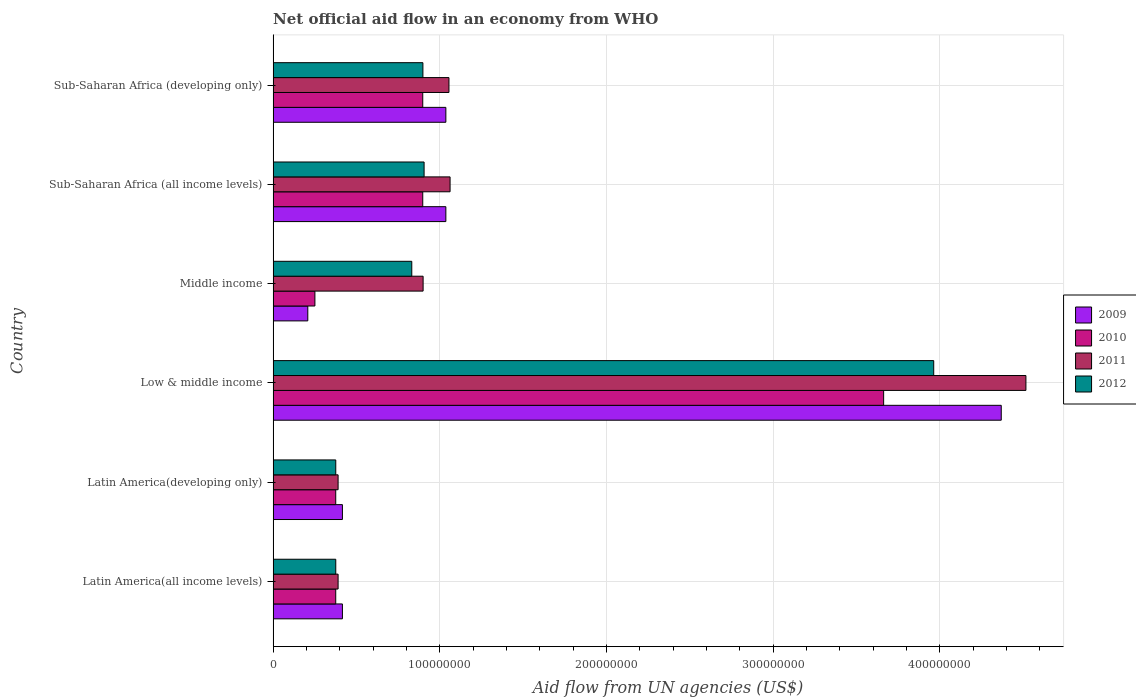Are the number of bars per tick equal to the number of legend labels?
Give a very brief answer. Yes. Are the number of bars on each tick of the Y-axis equal?
Provide a short and direct response. Yes. How many bars are there on the 6th tick from the top?
Offer a terse response. 4. How many bars are there on the 2nd tick from the bottom?
Provide a short and direct response. 4. What is the label of the 6th group of bars from the top?
Keep it short and to the point. Latin America(all income levels). What is the net official aid flow in 2010 in Latin America(all income levels)?
Your answer should be compact. 3.76e+07. Across all countries, what is the maximum net official aid flow in 2010?
Keep it short and to the point. 3.66e+08. Across all countries, what is the minimum net official aid flow in 2010?
Your answer should be compact. 2.51e+07. What is the total net official aid flow in 2012 in the graph?
Your answer should be very brief. 7.35e+08. What is the difference between the net official aid flow in 2010 in Middle income and that in Sub-Saharan Africa (all income levels)?
Offer a very short reply. -6.47e+07. What is the difference between the net official aid flow in 2012 in Sub-Saharan Africa (all income levels) and the net official aid flow in 2009 in Low & middle income?
Give a very brief answer. -3.46e+08. What is the average net official aid flow in 2010 per country?
Your response must be concise. 1.08e+08. What is the difference between the net official aid flow in 2009 and net official aid flow in 2011 in Sub-Saharan Africa (all income levels)?
Offer a terse response. -2.53e+06. In how many countries, is the net official aid flow in 2012 greater than 40000000 US$?
Make the answer very short. 4. What is the ratio of the net official aid flow in 2010 in Latin America(developing only) to that in Sub-Saharan Africa (all income levels)?
Your answer should be compact. 0.42. Is the net official aid flow in 2010 in Middle income less than that in Sub-Saharan Africa (all income levels)?
Offer a terse response. Yes. Is the difference between the net official aid flow in 2009 in Latin America(developing only) and Sub-Saharan Africa (developing only) greater than the difference between the net official aid flow in 2011 in Latin America(developing only) and Sub-Saharan Africa (developing only)?
Your response must be concise. Yes. What is the difference between the highest and the second highest net official aid flow in 2009?
Your answer should be compact. 3.33e+08. What is the difference between the highest and the lowest net official aid flow in 2010?
Your answer should be very brief. 3.41e+08. Is the sum of the net official aid flow in 2011 in Latin America(developing only) and Sub-Saharan Africa (all income levels) greater than the maximum net official aid flow in 2010 across all countries?
Make the answer very short. No. Is it the case that in every country, the sum of the net official aid flow in 2009 and net official aid flow in 2011 is greater than the net official aid flow in 2012?
Ensure brevity in your answer.  Yes. Are all the bars in the graph horizontal?
Offer a very short reply. Yes. How many countries are there in the graph?
Offer a very short reply. 6. Are the values on the major ticks of X-axis written in scientific E-notation?
Give a very brief answer. No. How many legend labels are there?
Your answer should be compact. 4. How are the legend labels stacked?
Your answer should be very brief. Vertical. What is the title of the graph?
Your response must be concise. Net official aid flow in an economy from WHO. What is the label or title of the X-axis?
Offer a very short reply. Aid flow from UN agencies (US$). What is the Aid flow from UN agencies (US$) in 2009 in Latin America(all income levels)?
Ensure brevity in your answer.  4.16e+07. What is the Aid flow from UN agencies (US$) of 2010 in Latin America(all income levels)?
Keep it short and to the point. 3.76e+07. What is the Aid flow from UN agencies (US$) in 2011 in Latin America(all income levels)?
Offer a very short reply. 3.90e+07. What is the Aid flow from UN agencies (US$) in 2012 in Latin America(all income levels)?
Give a very brief answer. 3.76e+07. What is the Aid flow from UN agencies (US$) in 2009 in Latin America(developing only)?
Keep it short and to the point. 4.16e+07. What is the Aid flow from UN agencies (US$) of 2010 in Latin America(developing only)?
Offer a terse response. 3.76e+07. What is the Aid flow from UN agencies (US$) in 2011 in Latin America(developing only)?
Your response must be concise. 3.90e+07. What is the Aid flow from UN agencies (US$) in 2012 in Latin America(developing only)?
Provide a succinct answer. 3.76e+07. What is the Aid flow from UN agencies (US$) in 2009 in Low & middle income?
Keep it short and to the point. 4.37e+08. What is the Aid flow from UN agencies (US$) of 2010 in Low & middle income?
Offer a terse response. 3.66e+08. What is the Aid flow from UN agencies (US$) in 2011 in Low & middle income?
Offer a terse response. 4.52e+08. What is the Aid flow from UN agencies (US$) of 2012 in Low & middle income?
Offer a very short reply. 3.96e+08. What is the Aid flow from UN agencies (US$) of 2009 in Middle income?
Ensure brevity in your answer.  2.08e+07. What is the Aid flow from UN agencies (US$) in 2010 in Middle income?
Offer a very short reply. 2.51e+07. What is the Aid flow from UN agencies (US$) of 2011 in Middle income?
Your answer should be very brief. 9.00e+07. What is the Aid flow from UN agencies (US$) in 2012 in Middle income?
Keep it short and to the point. 8.32e+07. What is the Aid flow from UN agencies (US$) in 2009 in Sub-Saharan Africa (all income levels)?
Offer a terse response. 1.04e+08. What is the Aid flow from UN agencies (US$) of 2010 in Sub-Saharan Africa (all income levels)?
Provide a succinct answer. 8.98e+07. What is the Aid flow from UN agencies (US$) in 2011 in Sub-Saharan Africa (all income levels)?
Provide a short and direct response. 1.06e+08. What is the Aid flow from UN agencies (US$) of 2012 in Sub-Saharan Africa (all income levels)?
Your answer should be compact. 9.06e+07. What is the Aid flow from UN agencies (US$) in 2009 in Sub-Saharan Africa (developing only)?
Ensure brevity in your answer.  1.04e+08. What is the Aid flow from UN agencies (US$) of 2010 in Sub-Saharan Africa (developing only)?
Offer a very short reply. 8.98e+07. What is the Aid flow from UN agencies (US$) of 2011 in Sub-Saharan Africa (developing only)?
Offer a terse response. 1.05e+08. What is the Aid flow from UN agencies (US$) of 2012 in Sub-Saharan Africa (developing only)?
Provide a short and direct response. 8.98e+07. Across all countries, what is the maximum Aid flow from UN agencies (US$) of 2009?
Offer a very short reply. 4.37e+08. Across all countries, what is the maximum Aid flow from UN agencies (US$) of 2010?
Your answer should be very brief. 3.66e+08. Across all countries, what is the maximum Aid flow from UN agencies (US$) in 2011?
Your answer should be very brief. 4.52e+08. Across all countries, what is the maximum Aid flow from UN agencies (US$) in 2012?
Your answer should be very brief. 3.96e+08. Across all countries, what is the minimum Aid flow from UN agencies (US$) of 2009?
Offer a terse response. 2.08e+07. Across all countries, what is the minimum Aid flow from UN agencies (US$) of 2010?
Offer a terse response. 2.51e+07. Across all countries, what is the minimum Aid flow from UN agencies (US$) of 2011?
Provide a succinct answer. 3.90e+07. Across all countries, what is the minimum Aid flow from UN agencies (US$) in 2012?
Your answer should be compact. 3.76e+07. What is the total Aid flow from UN agencies (US$) in 2009 in the graph?
Provide a succinct answer. 7.48e+08. What is the total Aid flow from UN agencies (US$) of 2010 in the graph?
Your response must be concise. 6.46e+08. What is the total Aid flow from UN agencies (US$) in 2011 in the graph?
Make the answer very short. 8.31e+08. What is the total Aid flow from UN agencies (US$) in 2012 in the graph?
Keep it short and to the point. 7.35e+08. What is the difference between the Aid flow from UN agencies (US$) of 2010 in Latin America(all income levels) and that in Latin America(developing only)?
Your response must be concise. 0. What is the difference between the Aid flow from UN agencies (US$) of 2011 in Latin America(all income levels) and that in Latin America(developing only)?
Ensure brevity in your answer.  0. What is the difference between the Aid flow from UN agencies (US$) in 2009 in Latin America(all income levels) and that in Low & middle income?
Your answer should be very brief. -3.95e+08. What is the difference between the Aid flow from UN agencies (US$) in 2010 in Latin America(all income levels) and that in Low & middle income?
Make the answer very short. -3.29e+08. What is the difference between the Aid flow from UN agencies (US$) of 2011 in Latin America(all income levels) and that in Low & middle income?
Provide a succinct answer. -4.13e+08. What is the difference between the Aid flow from UN agencies (US$) in 2012 in Latin America(all income levels) and that in Low & middle income?
Your answer should be compact. -3.59e+08. What is the difference between the Aid flow from UN agencies (US$) of 2009 in Latin America(all income levels) and that in Middle income?
Your answer should be compact. 2.08e+07. What is the difference between the Aid flow from UN agencies (US$) in 2010 in Latin America(all income levels) and that in Middle income?
Keep it short and to the point. 1.25e+07. What is the difference between the Aid flow from UN agencies (US$) in 2011 in Latin America(all income levels) and that in Middle income?
Provide a succinct answer. -5.10e+07. What is the difference between the Aid flow from UN agencies (US$) of 2012 in Latin America(all income levels) and that in Middle income?
Your answer should be compact. -4.56e+07. What is the difference between the Aid flow from UN agencies (US$) in 2009 in Latin America(all income levels) and that in Sub-Saharan Africa (all income levels)?
Make the answer very short. -6.20e+07. What is the difference between the Aid flow from UN agencies (US$) of 2010 in Latin America(all income levels) and that in Sub-Saharan Africa (all income levels)?
Make the answer very short. -5.22e+07. What is the difference between the Aid flow from UN agencies (US$) in 2011 in Latin America(all income levels) and that in Sub-Saharan Africa (all income levels)?
Make the answer very short. -6.72e+07. What is the difference between the Aid flow from UN agencies (US$) of 2012 in Latin America(all income levels) and that in Sub-Saharan Africa (all income levels)?
Your answer should be very brief. -5.30e+07. What is the difference between the Aid flow from UN agencies (US$) in 2009 in Latin America(all income levels) and that in Sub-Saharan Africa (developing only)?
Keep it short and to the point. -6.20e+07. What is the difference between the Aid flow from UN agencies (US$) of 2010 in Latin America(all income levels) and that in Sub-Saharan Africa (developing only)?
Offer a very short reply. -5.22e+07. What is the difference between the Aid flow from UN agencies (US$) in 2011 in Latin America(all income levels) and that in Sub-Saharan Africa (developing only)?
Your answer should be compact. -6.65e+07. What is the difference between the Aid flow from UN agencies (US$) in 2012 in Latin America(all income levels) and that in Sub-Saharan Africa (developing only)?
Offer a terse response. -5.23e+07. What is the difference between the Aid flow from UN agencies (US$) in 2009 in Latin America(developing only) and that in Low & middle income?
Your answer should be compact. -3.95e+08. What is the difference between the Aid flow from UN agencies (US$) in 2010 in Latin America(developing only) and that in Low & middle income?
Your response must be concise. -3.29e+08. What is the difference between the Aid flow from UN agencies (US$) of 2011 in Latin America(developing only) and that in Low & middle income?
Keep it short and to the point. -4.13e+08. What is the difference between the Aid flow from UN agencies (US$) in 2012 in Latin America(developing only) and that in Low & middle income?
Keep it short and to the point. -3.59e+08. What is the difference between the Aid flow from UN agencies (US$) in 2009 in Latin America(developing only) and that in Middle income?
Offer a very short reply. 2.08e+07. What is the difference between the Aid flow from UN agencies (US$) in 2010 in Latin America(developing only) and that in Middle income?
Your answer should be very brief. 1.25e+07. What is the difference between the Aid flow from UN agencies (US$) of 2011 in Latin America(developing only) and that in Middle income?
Provide a short and direct response. -5.10e+07. What is the difference between the Aid flow from UN agencies (US$) of 2012 in Latin America(developing only) and that in Middle income?
Offer a terse response. -4.56e+07. What is the difference between the Aid flow from UN agencies (US$) in 2009 in Latin America(developing only) and that in Sub-Saharan Africa (all income levels)?
Give a very brief answer. -6.20e+07. What is the difference between the Aid flow from UN agencies (US$) in 2010 in Latin America(developing only) and that in Sub-Saharan Africa (all income levels)?
Give a very brief answer. -5.22e+07. What is the difference between the Aid flow from UN agencies (US$) of 2011 in Latin America(developing only) and that in Sub-Saharan Africa (all income levels)?
Ensure brevity in your answer.  -6.72e+07. What is the difference between the Aid flow from UN agencies (US$) of 2012 in Latin America(developing only) and that in Sub-Saharan Africa (all income levels)?
Your answer should be very brief. -5.30e+07. What is the difference between the Aid flow from UN agencies (US$) of 2009 in Latin America(developing only) and that in Sub-Saharan Africa (developing only)?
Your response must be concise. -6.20e+07. What is the difference between the Aid flow from UN agencies (US$) in 2010 in Latin America(developing only) and that in Sub-Saharan Africa (developing only)?
Ensure brevity in your answer.  -5.22e+07. What is the difference between the Aid flow from UN agencies (US$) in 2011 in Latin America(developing only) and that in Sub-Saharan Africa (developing only)?
Give a very brief answer. -6.65e+07. What is the difference between the Aid flow from UN agencies (US$) of 2012 in Latin America(developing only) and that in Sub-Saharan Africa (developing only)?
Keep it short and to the point. -5.23e+07. What is the difference between the Aid flow from UN agencies (US$) of 2009 in Low & middle income and that in Middle income?
Ensure brevity in your answer.  4.16e+08. What is the difference between the Aid flow from UN agencies (US$) in 2010 in Low & middle income and that in Middle income?
Your answer should be very brief. 3.41e+08. What is the difference between the Aid flow from UN agencies (US$) of 2011 in Low & middle income and that in Middle income?
Provide a short and direct response. 3.62e+08. What is the difference between the Aid flow from UN agencies (US$) in 2012 in Low & middle income and that in Middle income?
Your response must be concise. 3.13e+08. What is the difference between the Aid flow from UN agencies (US$) of 2009 in Low & middle income and that in Sub-Saharan Africa (all income levels)?
Offer a very short reply. 3.33e+08. What is the difference between the Aid flow from UN agencies (US$) of 2010 in Low & middle income and that in Sub-Saharan Africa (all income levels)?
Give a very brief answer. 2.76e+08. What is the difference between the Aid flow from UN agencies (US$) in 2011 in Low & middle income and that in Sub-Saharan Africa (all income levels)?
Offer a very short reply. 3.45e+08. What is the difference between the Aid flow from UN agencies (US$) of 2012 in Low & middle income and that in Sub-Saharan Africa (all income levels)?
Offer a terse response. 3.06e+08. What is the difference between the Aid flow from UN agencies (US$) of 2009 in Low & middle income and that in Sub-Saharan Africa (developing only)?
Provide a short and direct response. 3.33e+08. What is the difference between the Aid flow from UN agencies (US$) of 2010 in Low & middle income and that in Sub-Saharan Africa (developing only)?
Your response must be concise. 2.76e+08. What is the difference between the Aid flow from UN agencies (US$) in 2011 in Low & middle income and that in Sub-Saharan Africa (developing only)?
Offer a terse response. 3.46e+08. What is the difference between the Aid flow from UN agencies (US$) in 2012 in Low & middle income and that in Sub-Saharan Africa (developing only)?
Your answer should be compact. 3.06e+08. What is the difference between the Aid flow from UN agencies (US$) in 2009 in Middle income and that in Sub-Saharan Africa (all income levels)?
Your response must be concise. -8.28e+07. What is the difference between the Aid flow from UN agencies (US$) in 2010 in Middle income and that in Sub-Saharan Africa (all income levels)?
Provide a succinct answer. -6.47e+07. What is the difference between the Aid flow from UN agencies (US$) of 2011 in Middle income and that in Sub-Saharan Africa (all income levels)?
Keep it short and to the point. -1.62e+07. What is the difference between the Aid flow from UN agencies (US$) of 2012 in Middle income and that in Sub-Saharan Africa (all income levels)?
Give a very brief answer. -7.39e+06. What is the difference between the Aid flow from UN agencies (US$) of 2009 in Middle income and that in Sub-Saharan Africa (developing only)?
Your response must be concise. -8.28e+07. What is the difference between the Aid flow from UN agencies (US$) in 2010 in Middle income and that in Sub-Saharan Africa (developing only)?
Make the answer very short. -6.47e+07. What is the difference between the Aid flow from UN agencies (US$) in 2011 in Middle income and that in Sub-Saharan Africa (developing only)?
Your answer should be very brief. -1.55e+07. What is the difference between the Aid flow from UN agencies (US$) in 2012 in Middle income and that in Sub-Saharan Africa (developing only)?
Keep it short and to the point. -6.67e+06. What is the difference between the Aid flow from UN agencies (US$) in 2009 in Sub-Saharan Africa (all income levels) and that in Sub-Saharan Africa (developing only)?
Your answer should be compact. 0. What is the difference between the Aid flow from UN agencies (US$) of 2010 in Sub-Saharan Africa (all income levels) and that in Sub-Saharan Africa (developing only)?
Keep it short and to the point. 0. What is the difference between the Aid flow from UN agencies (US$) in 2011 in Sub-Saharan Africa (all income levels) and that in Sub-Saharan Africa (developing only)?
Provide a short and direct response. 6.70e+05. What is the difference between the Aid flow from UN agencies (US$) in 2012 in Sub-Saharan Africa (all income levels) and that in Sub-Saharan Africa (developing only)?
Offer a very short reply. 7.20e+05. What is the difference between the Aid flow from UN agencies (US$) in 2009 in Latin America(all income levels) and the Aid flow from UN agencies (US$) in 2010 in Latin America(developing only)?
Keep it short and to the point. 4.01e+06. What is the difference between the Aid flow from UN agencies (US$) of 2009 in Latin America(all income levels) and the Aid flow from UN agencies (US$) of 2011 in Latin America(developing only)?
Give a very brief answer. 2.59e+06. What is the difference between the Aid flow from UN agencies (US$) in 2009 in Latin America(all income levels) and the Aid flow from UN agencies (US$) in 2012 in Latin America(developing only)?
Your response must be concise. 3.99e+06. What is the difference between the Aid flow from UN agencies (US$) in 2010 in Latin America(all income levels) and the Aid flow from UN agencies (US$) in 2011 in Latin America(developing only)?
Provide a succinct answer. -1.42e+06. What is the difference between the Aid flow from UN agencies (US$) of 2011 in Latin America(all income levels) and the Aid flow from UN agencies (US$) of 2012 in Latin America(developing only)?
Make the answer very short. 1.40e+06. What is the difference between the Aid flow from UN agencies (US$) of 2009 in Latin America(all income levels) and the Aid flow from UN agencies (US$) of 2010 in Low & middle income?
Make the answer very short. -3.25e+08. What is the difference between the Aid flow from UN agencies (US$) of 2009 in Latin America(all income levels) and the Aid flow from UN agencies (US$) of 2011 in Low & middle income?
Your answer should be compact. -4.10e+08. What is the difference between the Aid flow from UN agencies (US$) in 2009 in Latin America(all income levels) and the Aid flow from UN agencies (US$) in 2012 in Low & middle income?
Make the answer very short. -3.55e+08. What is the difference between the Aid flow from UN agencies (US$) of 2010 in Latin America(all income levels) and the Aid flow from UN agencies (US$) of 2011 in Low & middle income?
Provide a succinct answer. -4.14e+08. What is the difference between the Aid flow from UN agencies (US$) of 2010 in Latin America(all income levels) and the Aid flow from UN agencies (US$) of 2012 in Low & middle income?
Your response must be concise. -3.59e+08. What is the difference between the Aid flow from UN agencies (US$) of 2011 in Latin America(all income levels) and the Aid flow from UN agencies (US$) of 2012 in Low & middle income?
Ensure brevity in your answer.  -3.57e+08. What is the difference between the Aid flow from UN agencies (US$) of 2009 in Latin America(all income levels) and the Aid flow from UN agencies (US$) of 2010 in Middle income?
Keep it short and to the point. 1.65e+07. What is the difference between the Aid flow from UN agencies (US$) of 2009 in Latin America(all income levels) and the Aid flow from UN agencies (US$) of 2011 in Middle income?
Offer a very short reply. -4.84e+07. What is the difference between the Aid flow from UN agencies (US$) of 2009 in Latin America(all income levels) and the Aid flow from UN agencies (US$) of 2012 in Middle income?
Your answer should be compact. -4.16e+07. What is the difference between the Aid flow from UN agencies (US$) in 2010 in Latin America(all income levels) and the Aid flow from UN agencies (US$) in 2011 in Middle income?
Your answer should be compact. -5.24e+07. What is the difference between the Aid flow from UN agencies (US$) of 2010 in Latin America(all income levels) and the Aid flow from UN agencies (US$) of 2012 in Middle income?
Make the answer very short. -4.56e+07. What is the difference between the Aid flow from UN agencies (US$) of 2011 in Latin America(all income levels) and the Aid flow from UN agencies (US$) of 2012 in Middle income?
Offer a terse response. -4.42e+07. What is the difference between the Aid flow from UN agencies (US$) in 2009 in Latin America(all income levels) and the Aid flow from UN agencies (US$) in 2010 in Sub-Saharan Africa (all income levels)?
Offer a very short reply. -4.82e+07. What is the difference between the Aid flow from UN agencies (US$) in 2009 in Latin America(all income levels) and the Aid flow from UN agencies (US$) in 2011 in Sub-Saharan Africa (all income levels)?
Your answer should be compact. -6.46e+07. What is the difference between the Aid flow from UN agencies (US$) of 2009 in Latin America(all income levels) and the Aid flow from UN agencies (US$) of 2012 in Sub-Saharan Africa (all income levels)?
Offer a very short reply. -4.90e+07. What is the difference between the Aid flow from UN agencies (US$) in 2010 in Latin America(all income levels) and the Aid flow from UN agencies (US$) in 2011 in Sub-Saharan Africa (all income levels)?
Give a very brief answer. -6.86e+07. What is the difference between the Aid flow from UN agencies (US$) in 2010 in Latin America(all income levels) and the Aid flow from UN agencies (US$) in 2012 in Sub-Saharan Africa (all income levels)?
Offer a very short reply. -5.30e+07. What is the difference between the Aid flow from UN agencies (US$) of 2011 in Latin America(all income levels) and the Aid flow from UN agencies (US$) of 2012 in Sub-Saharan Africa (all income levels)?
Your answer should be compact. -5.16e+07. What is the difference between the Aid flow from UN agencies (US$) in 2009 in Latin America(all income levels) and the Aid flow from UN agencies (US$) in 2010 in Sub-Saharan Africa (developing only)?
Provide a succinct answer. -4.82e+07. What is the difference between the Aid flow from UN agencies (US$) in 2009 in Latin America(all income levels) and the Aid flow from UN agencies (US$) in 2011 in Sub-Saharan Africa (developing only)?
Your response must be concise. -6.39e+07. What is the difference between the Aid flow from UN agencies (US$) of 2009 in Latin America(all income levels) and the Aid flow from UN agencies (US$) of 2012 in Sub-Saharan Africa (developing only)?
Ensure brevity in your answer.  -4.83e+07. What is the difference between the Aid flow from UN agencies (US$) of 2010 in Latin America(all income levels) and the Aid flow from UN agencies (US$) of 2011 in Sub-Saharan Africa (developing only)?
Give a very brief answer. -6.79e+07. What is the difference between the Aid flow from UN agencies (US$) of 2010 in Latin America(all income levels) and the Aid flow from UN agencies (US$) of 2012 in Sub-Saharan Africa (developing only)?
Your response must be concise. -5.23e+07. What is the difference between the Aid flow from UN agencies (US$) in 2011 in Latin America(all income levels) and the Aid flow from UN agencies (US$) in 2012 in Sub-Saharan Africa (developing only)?
Provide a succinct answer. -5.09e+07. What is the difference between the Aid flow from UN agencies (US$) in 2009 in Latin America(developing only) and the Aid flow from UN agencies (US$) in 2010 in Low & middle income?
Offer a very short reply. -3.25e+08. What is the difference between the Aid flow from UN agencies (US$) of 2009 in Latin America(developing only) and the Aid flow from UN agencies (US$) of 2011 in Low & middle income?
Provide a succinct answer. -4.10e+08. What is the difference between the Aid flow from UN agencies (US$) in 2009 in Latin America(developing only) and the Aid flow from UN agencies (US$) in 2012 in Low & middle income?
Provide a short and direct response. -3.55e+08. What is the difference between the Aid flow from UN agencies (US$) of 2010 in Latin America(developing only) and the Aid flow from UN agencies (US$) of 2011 in Low & middle income?
Provide a short and direct response. -4.14e+08. What is the difference between the Aid flow from UN agencies (US$) in 2010 in Latin America(developing only) and the Aid flow from UN agencies (US$) in 2012 in Low & middle income?
Keep it short and to the point. -3.59e+08. What is the difference between the Aid flow from UN agencies (US$) in 2011 in Latin America(developing only) and the Aid flow from UN agencies (US$) in 2012 in Low & middle income?
Your response must be concise. -3.57e+08. What is the difference between the Aid flow from UN agencies (US$) of 2009 in Latin America(developing only) and the Aid flow from UN agencies (US$) of 2010 in Middle income?
Provide a succinct answer. 1.65e+07. What is the difference between the Aid flow from UN agencies (US$) in 2009 in Latin America(developing only) and the Aid flow from UN agencies (US$) in 2011 in Middle income?
Provide a short and direct response. -4.84e+07. What is the difference between the Aid flow from UN agencies (US$) in 2009 in Latin America(developing only) and the Aid flow from UN agencies (US$) in 2012 in Middle income?
Provide a succinct answer. -4.16e+07. What is the difference between the Aid flow from UN agencies (US$) in 2010 in Latin America(developing only) and the Aid flow from UN agencies (US$) in 2011 in Middle income?
Make the answer very short. -5.24e+07. What is the difference between the Aid flow from UN agencies (US$) in 2010 in Latin America(developing only) and the Aid flow from UN agencies (US$) in 2012 in Middle income?
Offer a terse response. -4.56e+07. What is the difference between the Aid flow from UN agencies (US$) of 2011 in Latin America(developing only) and the Aid flow from UN agencies (US$) of 2012 in Middle income?
Give a very brief answer. -4.42e+07. What is the difference between the Aid flow from UN agencies (US$) of 2009 in Latin America(developing only) and the Aid flow from UN agencies (US$) of 2010 in Sub-Saharan Africa (all income levels)?
Make the answer very short. -4.82e+07. What is the difference between the Aid flow from UN agencies (US$) of 2009 in Latin America(developing only) and the Aid flow from UN agencies (US$) of 2011 in Sub-Saharan Africa (all income levels)?
Offer a very short reply. -6.46e+07. What is the difference between the Aid flow from UN agencies (US$) of 2009 in Latin America(developing only) and the Aid flow from UN agencies (US$) of 2012 in Sub-Saharan Africa (all income levels)?
Make the answer very short. -4.90e+07. What is the difference between the Aid flow from UN agencies (US$) of 2010 in Latin America(developing only) and the Aid flow from UN agencies (US$) of 2011 in Sub-Saharan Africa (all income levels)?
Provide a succinct answer. -6.86e+07. What is the difference between the Aid flow from UN agencies (US$) of 2010 in Latin America(developing only) and the Aid flow from UN agencies (US$) of 2012 in Sub-Saharan Africa (all income levels)?
Ensure brevity in your answer.  -5.30e+07. What is the difference between the Aid flow from UN agencies (US$) in 2011 in Latin America(developing only) and the Aid flow from UN agencies (US$) in 2012 in Sub-Saharan Africa (all income levels)?
Give a very brief answer. -5.16e+07. What is the difference between the Aid flow from UN agencies (US$) in 2009 in Latin America(developing only) and the Aid flow from UN agencies (US$) in 2010 in Sub-Saharan Africa (developing only)?
Your response must be concise. -4.82e+07. What is the difference between the Aid flow from UN agencies (US$) in 2009 in Latin America(developing only) and the Aid flow from UN agencies (US$) in 2011 in Sub-Saharan Africa (developing only)?
Your response must be concise. -6.39e+07. What is the difference between the Aid flow from UN agencies (US$) in 2009 in Latin America(developing only) and the Aid flow from UN agencies (US$) in 2012 in Sub-Saharan Africa (developing only)?
Give a very brief answer. -4.83e+07. What is the difference between the Aid flow from UN agencies (US$) in 2010 in Latin America(developing only) and the Aid flow from UN agencies (US$) in 2011 in Sub-Saharan Africa (developing only)?
Your answer should be compact. -6.79e+07. What is the difference between the Aid flow from UN agencies (US$) in 2010 in Latin America(developing only) and the Aid flow from UN agencies (US$) in 2012 in Sub-Saharan Africa (developing only)?
Provide a succinct answer. -5.23e+07. What is the difference between the Aid flow from UN agencies (US$) of 2011 in Latin America(developing only) and the Aid flow from UN agencies (US$) of 2012 in Sub-Saharan Africa (developing only)?
Your answer should be compact. -5.09e+07. What is the difference between the Aid flow from UN agencies (US$) in 2009 in Low & middle income and the Aid flow from UN agencies (US$) in 2010 in Middle income?
Offer a terse response. 4.12e+08. What is the difference between the Aid flow from UN agencies (US$) of 2009 in Low & middle income and the Aid flow from UN agencies (US$) of 2011 in Middle income?
Offer a very short reply. 3.47e+08. What is the difference between the Aid flow from UN agencies (US$) of 2009 in Low & middle income and the Aid flow from UN agencies (US$) of 2012 in Middle income?
Provide a short and direct response. 3.54e+08. What is the difference between the Aid flow from UN agencies (US$) in 2010 in Low & middle income and the Aid flow from UN agencies (US$) in 2011 in Middle income?
Ensure brevity in your answer.  2.76e+08. What is the difference between the Aid flow from UN agencies (US$) of 2010 in Low & middle income and the Aid flow from UN agencies (US$) of 2012 in Middle income?
Ensure brevity in your answer.  2.83e+08. What is the difference between the Aid flow from UN agencies (US$) of 2011 in Low & middle income and the Aid flow from UN agencies (US$) of 2012 in Middle income?
Make the answer very short. 3.68e+08. What is the difference between the Aid flow from UN agencies (US$) in 2009 in Low & middle income and the Aid flow from UN agencies (US$) in 2010 in Sub-Saharan Africa (all income levels)?
Your answer should be compact. 3.47e+08. What is the difference between the Aid flow from UN agencies (US$) in 2009 in Low & middle income and the Aid flow from UN agencies (US$) in 2011 in Sub-Saharan Africa (all income levels)?
Provide a short and direct response. 3.31e+08. What is the difference between the Aid flow from UN agencies (US$) in 2009 in Low & middle income and the Aid flow from UN agencies (US$) in 2012 in Sub-Saharan Africa (all income levels)?
Keep it short and to the point. 3.46e+08. What is the difference between the Aid flow from UN agencies (US$) of 2010 in Low & middle income and the Aid flow from UN agencies (US$) of 2011 in Sub-Saharan Africa (all income levels)?
Make the answer very short. 2.60e+08. What is the difference between the Aid flow from UN agencies (US$) in 2010 in Low & middle income and the Aid flow from UN agencies (US$) in 2012 in Sub-Saharan Africa (all income levels)?
Make the answer very short. 2.76e+08. What is the difference between the Aid flow from UN agencies (US$) of 2011 in Low & middle income and the Aid flow from UN agencies (US$) of 2012 in Sub-Saharan Africa (all income levels)?
Give a very brief answer. 3.61e+08. What is the difference between the Aid flow from UN agencies (US$) in 2009 in Low & middle income and the Aid flow from UN agencies (US$) in 2010 in Sub-Saharan Africa (developing only)?
Make the answer very short. 3.47e+08. What is the difference between the Aid flow from UN agencies (US$) of 2009 in Low & middle income and the Aid flow from UN agencies (US$) of 2011 in Sub-Saharan Africa (developing only)?
Your answer should be very brief. 3.31e+08. What is the difference between the Aid flow from UN agencies (US$) in 2009 in Low & middle income and the Aid flow from UN agencies (US$) in 2012 in Sub-Saharan Africa (developing only)?
Your answer should be very brief. 3.47e+08. What is the difference between the Aid flow from UN agencies (US$) of 2010 in Low & middle income and the Aid flow from UN agencies (US$) of 2011 in Sub-Saharan Africa (developing only)?
Offer a terse response. 2.61e+08. What is the difference between the Aid flow from UN agencies (US$) of 2010 in Low & middle income and the Aid flow from UN agencies (US$) of 2012 in Sub-Saharan Africa (developing only)?
Offer a very short reply. 2.76e+08. What is the difference between the Aid flow from UN agencies (US$) of 2011 in Low & middle income and the Aid flow from UN agencies (US$) of 2012 in Sub-Saharan Africa (developing only)?
Keep it short and to the point. 3.62e+08. What is the difference between the Aid flow from UN agencies (US$) in 2009 in Middle income and the Aid flow from UN agencies (US$) in 2010 in Sub-Saharan Africa (all income levels)?
Give a very brief answer. -6.90e+07. What is the difference between the Aid flow from UN agencies (US$) of 2009 in Middle income and the Aid flow from UN agencies (US$) of 2011 in Sub-Saharan Africa (all income levels)?
Make the answer very short. -8.54e+07. What is the difference between the Aid flow from UN agencies (US$) of 2009 in Middle income and the Aid flow from UN agencies (US$) of 2012 in Sub-Saharan Africa (all income levels)?
Offer a very short reply. -6.98e+07. What is the difference between the Aid flow from UN agencies (US$) in 2010 in Middle income and the Aid flow from UN agencies (US$) in 2011 in Sub-Saharan Africa (all income levels)?
Offer a very short reply. -8.11e+07. What is the difference between the Aid flow from UN agencies (US$) in 2010 in Middle income and the Aid flow from UN agencies (US$) in 2012 in Sub-Saharan Africa (all income levels)?
Your answer should be very brief. -6.55e+07. What is the difference between the Aid flow from UN agencies (US$) in 2011 in Middle income and the Aid flow from UN agencies (US$) in 2012 in Sub-Saharan Africa (all income levels)?
Your answer should be compact. -5.90e+05. What is the difference between the Aid flow from UN agencies (US$) in 2009 in Middle income and the Aid flow from UN agencies (US$) in 2010 in Sub-Saharan Africa (developing only)?
Keep it short and to the point. -6.90e+07. What is the difference between the Aid flow from UN agencies (US$) in 2009 in Middle income and the Aid flow from UN agencies (US$) in 2011 in Sub-Saharan Africa (developing only)?
Offer a very short reply. -8.47e+07. What is the difference between the Aid flow from UN agencies (US$) in 2009 in Middle income and the Aid flow from UN agencies (US$) in 2012 in Sub-Saharan Africa (developing only)?
Provide a succinct answer. -6.90e+07. What is the difference between the Aid flow from UN agencies (US$) in 2010 in Middle income and the Aid flow from UN agencies (US$) in 2011 in Sub-Saharan Africa (developing only)?
Your answer should be very brief. -8.04e+07. What is the difference between the Aid flow from UN agencies (US$) of 2010 in Middle income and the Aid flow from UN agencies (US$) of 2012 in Sub-Saharan Africa (developing only)?
Your answer should be compact. -6.48e+07. What is the difference between the Aid flow from UN agencies (US$) of 2009 in Sub-Saharan Africa (all income levels) and the Aid flow from UN agencies (US$) of 2010 in Sub-Saharan Africa (developing only)?
Give a very brief answer. 1.39e+07. What is the difference between the Aid flow from UN agencies (US$) in 2009 in Sub-Saharan Africa (all income levels) and the Aid flow from UN agencies (US$) in 2011 in Sub-Saharan Africa (developing only)?
Give a very brief answer. -1.86e+06. What is the difference between the Aid flow from UN agencies (US$) of 2009 in Sub-Saharan Africa (all income levels) and the Aid flow from UN agencies (US$) of 2012 in Sub-Saharan Africa (developing only)?
Offer a terse response. 1.38e+07. What is the difference between the Aid flow from UN agencies (US$) in 2010 in Sub-Saharan Africa (all income levels) and the Aid flow from UN agencies (US$) in 2011 in Sub-Saharan Africa (developing only)?
Ensure brevity in your answer.  -1.57e+07. What is the difference between the Aid flow from UN agencies (US$) of 2011 in Sub-Saharan Africa (all income levels) and the Aid flow from UN agencies (US$) of 2012 in Sub-Saharan Africa (developing only)?
Make the answer very short. 1.63e+07. What is the average Aid flow from UN agencies (US$) of 2009 per country?
Provide a short and direct response. 1.25e+08. What is the average Aid flow from UN agencies (US$) of 2010 per country?
Your answer should be compact. 1.08e+08. What is the average Aid flow from UN agencies (US$) of 2011 per country?
Offer a very short reply. 1.39e+08. What is the average Aid flow from UN agencies (US$) of 2012 per country?
Offer a terse response. 1.23e+08. What is the difference between the Aid flow from UN agencies (US$) of 2009 and Aid flow from UN agencies (US$) of 2010 in Latin America(all income levels)?
Provide a short and direct response. 4.01e+06. What is the difference between the Aid flow from UN agencies (US$) in 2009 and Aid flow from UN agencies (US$) in 2011 in Latin America(all income levels)?
Offer a very short reply. 2.59e+06. What is the difference between the Aid flow from UN agencies (US$) of 2009 and Aid flow from UN agencies (US$) of 2012 in Latin America(all income levels)?
Ensure brevity in your answer.  3.99e+06. What is the difference between the Aid flow from UN agencies (US$) in 2010 and Aid flow from UN agencies (US$) in 2011 in Latin America(all income levels)?
Offer a very short reply. -1.42e+06. What is the difference between the Aid flow from UN agencies (US$) of 2011 and Aid flow from UN agencies (US$) of 2012 in Latin America(all income levels)?
Ensure brevity in your answer.  1.40e+06. What is the difference between the Aid flow from UN agencies (US$) of 2009 and Aid flow from UN agencies (US$) of 2010 in Latin America(developing only)?
Provide a succinct answer. 4.01e+06. What is the difference between the Aid flow from UN agencies (US$) in 2009 and Aid flow from UN agencies (US$) in 2011 in Latin America(developing only)?
Give a very brief answer. 2.59e+06. What is the difference between the Aid flow from UN agencies (US$) of 2009 and Aid flow from UN agencies (US$) of 2012 in Latin America(developing only)?
Keep it short and to the point. 3.99e+06. What is the difference between the Aid flow from UN agencies (US$) of 2010 and Aid flow from UN agencies (US$) of 2011 in Latin America(developing only)?
Give a very brief answer. -1.42e+06. What is the difference between the Aid flow from UN agencies (US$) of 2011 and Aid flow from UN agencies (US$) of 2012 in Latin America(developing only)?
Keep it short and to the point. 1.40e+06. What is the difference between the Aid flow from UN agencies (US$) of 2009 and Aid flow from UN agencies (US$) of 2010 in Low & middle income?
Your response must be concise. 7.06e+07. What is the difference between the Aid flow from UN agencies (US$) in 2009 and Aid flow from UN agencies (US$) in 2011 in Low & middle income?
Your answer should be very brief. -1.48e+07. What is the difference between the Aid flow from UN agencies (US$) of 2009 and Aid flow from UN agencies (US$) of 2012 in Low & middle income?
Your answer should be very brief. 4.05e+07. What is the difference between the Aid flow from UN agencies (US$) in 2010 and Aid flow from UN agencies (US$) in 2011 in Low & middle income?
Provide a succinct answer. -8.54e+07. What is the difference between the Aid flow from UN agencies (US$) in 2010 and Aid flow from UN agencies (US$) in 2012 in Low & middle income?
Make the answer very short. -3.00e+07. What is the difference between the Aid flow from UN agencies (US$) of 2011 and Aid flow from UN agencies (US$) of 2012 in Low & middle income?
Offer a very short reply. 5.53e+07. What is the difference between the Aid flow from UN agencies (US$) of 2009 and Aid flow from UN agencies (US$) of 2010 in Middle income?
Make the answer very short. -4.27e+06. What is the difference between the Aid flow from UN agencies (US$) in 2009 and Aid flow from UN agencies (US$) in 2011 in Middle income?
Ensure brevity in your answer.  -6.92e+07. What is the difference between the Aid flow from UN agencies (US$) of 2009 and Aid flow from UN agencies (US$) of 2012 in Middle income?
Provide a short and direct response. -6.24e+07. What is the difference between the Aid flow from UN agencies (US$) of 2010 and Aid flow from UN agencies (US$) of 2011 in Middle income?
Ensure brevity in your answer.  -6.49e+07. What is the difference between the Aid flow from UN agencies (US$) of 2010 and Aid flow from UN agencies (US$) of 2012 in Middle income?
Offer a terse response. -5.81e+07. What is the difference between the Aid flow from UN agencies (US$) in 2011 and Aid flow from UN agencies (US$) in 2012 in Middle income?
Provide a short and direct response. 6.80e+06. What is the difference between the Aid flow from UN agencies (US$) in 2009 and Aid flow from UN agencies (US$) in 2010 in Sub-Saharan Africa (all income levels)?
Provide a short and direct response. 1.39e+07. What is the difference between the Aid flow from UN agencies (US$) in 2009 and Aid flow from UN agencies (US$) in 2011 in Sub-Saharan Africa (all income levels)?
Keep it short and to the point. -2.53e+06. What is the difference between the Aid flow from UN agencies (US$) in 2009 and Aid flow from UN agencies (US$) in 2012 in Sub-Saharan Africa (all income levels)?
Your answer should be compact. 1.30e+07. What is the difference between the Aid flow from UN agencies (US$) of 2010 and Aid flow from UN agencies (US$) of 2011 in Sub-Saharan Africa (all income levels)?
Your answer should be very brief. -1.64e+07. What is the difference between the Aid flow from UN agencies (US$) in 2010 and Aid flow from UN agencies (US$) in 2012 in Sub-Saharan Africa (all income levels)?
Your response must be concise. -8.10e+05. What is the difference between the Aid flow from UN agencies (US$) of 2011 and Aid flow from UN agencies (US$) of 2012 in Sub-Saharan Africa (all income levels)?
Offer a very short reply. 1.56e+07. What is the difference between the Aid flow from UN agencies (US$) of 2009 and Aid flow from UN agencies (US$) of 2010 in Sub-Saharan Africa (developing only)?
Ensure brevity in your answer.  1.39e+07. What is the difference between the Aid flow from UN agencies (US$) in 2009 and Aid flow from UN agencies (US$) in 2011 in Sub-Saharan Africa (developing only)?
Keep it short and to the point. -1.86e+06. What is the difference between the Aid flow from UN agencies (US$) in 2009 and Aid flow from UN agencies (US$) in 2012 in Sub-Saharan Africa (developing only)?
Offer a very short reply. 1.38e+07. What is the difference between the Aid flow from UN agencies (US$) in 2010 and Aid flow from UN agencies (US$) in 2011 in Sub-Saharan Africa (developing only)?
Your response must be concise. -1.57e+07. What is the difference between the Aid flow from UN agencies (US$) of 2011 and Aid flow from UN agencies (US$) of 2012 in Sub-Saharan Africa (developing only)?
Make the answer very short. 1.56e+07. What is the ratio of the Aid flow from UN agencies (US$) in 2009 in Latin America(all income levels) to that in Latin America(developing only)?
Your answer should be very brief. 1. What is the ratio of the Aid flow from UN agencies (US$) of 2010 in Latin America(all income levels) to that in Latin America(developing only)?
Provide a short and direct response. 1. What is the ratio of the Aid flow from UN agencies (US$) in 2011 in Latin America(all income levels) to that in Latin America(developing only)?
Your response must be concise. 1. What is the ratio of the Aid flow from UN agencies (US$) in 2009 in Latin America(all income levels) to that in Low & middle income?
Give a very brief answer. 0.1. What is the ratio of the Aid flow from UN agencies (US$) of 2010 in Latin America(all income levels) to that in Low & middle income?
Your response must be concise. 0.1. What is the ratio of the Aid flow from UN agencies (US$) in 2011 in Latin America(all income levels) to that in Low & middle income?
Offer a terse response. 0.09. What is the ratio of the Aid flow from UN agencies (US$) in 2012 in Latin America(all income levels) to that in Low & middle income?
Offer a very short reply. 0.09. What is the ratio of the Aid flow from UN agencies (US$) in 2009 in Latin America(all income levels) to that in Middle income?
Offer a terse response. 2. What is the ratio of the Aid flow from UN agencies (US$) in 2010 in Latin America(all income levels) to that in Middle income?
Give a very brief answer. 1.5. What is the ratio of the Aid flow from UN agencies (US$) of 2011 in Latin America(all income levels) to that in Middle income?
Ensure brevity in your answer.  0.43. What is the ratio of the Aid flow from UN agencies (US$) in 2012 in Latin America(all income levels) to that in Middle income?
Keep it short and to the point. 0.45. What is the ratio of the Aid flow from UN agencies (US$) of 2009 in Latin America(all income levels) to that in Sub-Saharan Africa (all income levels)?
Your response must be concise. 0.4. What is the ratio of the Aid flow from UN agencies (US$) of 2010 in Latin America(all income levels) to that in Sub-Saharan Africa (all income levels)?
Make the answer very short. 0.42. What is the ratio of the Aid flow from UN agencies (US$) in 2011 in Latin America(all income levels) to that in Sub-Saharan Africa (all income levels)?
Make the answer very short. 0.37. What is the ratio of the Aid flow from UN agencies (US$) of 2012 in Latin America(all income levels) to that in Sub-Saharan Africa (all income levels)?
Provide a succinct answer. 0.41. What is the ratio of the Aid flow from UN agencies (US$) in 2009 in Latin America(all income levels) to that in Sub-Saharan Africa (developing only)?
Make the answer very short. 0.4. What is the ratio of the Aid flow from UN agencies (US$) of 2010 in Latin America(all income levels) to that in Sub-Saharan Africa (developing only)?
Offer a very short reply. 0.42. What is the ratio of the Aid flow from UN agencies (US$) of 2011 in Latin America(all income levels) to that in Sub-Saharan Africa (developing only)?
Provide a succinct answer. 0.37. What is the ratio of the Aid flow from UN agencies (US$) in 2012 in Latin America(all income levels) to that in Sub-Saharan Africa (developing only)?
Provide a short and direct response. 0.42. What is the ratio of the Aid flow from UN agencies (US$) of 2009 in Latin America(developing only) to that in Low & middle income?
Your answer should be compact. 0.1. What is the ratio of the Aid flow from UN agencies (US$) of 2010 in Latin America(developing only) to that in Low & middle income?
Keep it short and to the point. 0.1. What is the ratio of the Aid flow from UN agencies (US$) in 2011 in Latin America(developing only) to that in Low & middle income?
Provide a succinct answer. 0.09. What is the ratio of the Aid flow from UN agencies (US$) in 2012 in Latin America(developing only) to that in Low & middle income?
Offer a very short reply. 0.09. What is the ratio of the Aid flow from UN agencies (US$) in 2009 in Latin America(developing only) to that in Middle income?
Your response must be concise. 2. What is the ratio of the Aid flow from UN agencies (US$) in 2010 in Latin America(developing only) to that in Middle income?
Give a very brief answer. 1.5. What is the ratio of the Aid flow from UN agencies (US$) in 2011 in Latin America(developing only) to that in Middle income?
Give a very brief answer. 0.43. What is the ratio of the Aid flow from UN agencies (US$) in 2012 in Latin America(developing only) to that in Middle income?
Your answer should be very brief. 0.45. What is the ratio of the Aid flow from UN agencies (US$) of 2009 in Latin America(developing only) to that in Sub-Saharan Africa (all income levels)?
Provide a succinct answer. 0.4. What is the ratio of the Aid flow from UN agencies (US$) of 2010 in Latin America(developing only) to that in Sub-Saharan Africa (all income levels)?
Ensure brevity in your answer.  0.42. What is the ratio of the Aid flow from UN agencies (US$) of 2011 in Latin America(developing only) to that in Sub-Saharan Africa (all income levels)?
Your response must be concise. 0.37. What is the ratio of the Aid flow from UN agencies (US$) in 2012 in Latin America(developing only) to that in Sub-Saharan Africa (all income levels)?
Ensure brevity in your answer.  0.41. What is the ratio of the Aid flow from UN agencies (US$) in 2009 in Latin America(developing only) to that in Sub-Saharan Africa (developing only)?
Provide a short and direct response. 0.4. What is the ratio of the Aid flow from UN agencies (US$) of 2010 in Latin America(developing only) to that in Sub-Saharan Africa (developing only)?
Give a very brief answer. 0.42. What is the ratio of the Aid flow from UN agencies (US$) in 2011 in Latin America(developing only) to that in Sub-Saharan Africa (developing only)?
Keep it short and to the point. 0.37. What is the ratio of the Aid flow from UN agencies (US$) in 2012 in Latin America(developing only) to that in Sub-Saharan Africa (developing only)?
Keep it short and to the point. 0.42. What is the ratio of the Aid flow from UN agencies (US$) in 2009 in Low & middle income to that in Middle income?
Your answer should be very brief. 21. What is the ratio of the Aid flow from UN agencies (US$) of 2010 in Low & middle income to that in Middle income?
Make the answer very short. 14.61. What is the ratio of the Aid flow from UN agencies (US$) of 2011 in Low & middle income to that in Middle income?
Offer a very short reply. 5.02. What is the ratio of the Aid flow from UN agencies (US$) in 2012 in Low & middle income to that in Middle income?
Provide a succinct answer. 4.76. What is the ratio of the Aid flow from UN agencies (US$) of 2009 in Low & middle income to that in Sub-Saharan Africa (all income levels)?
Your answer should be very brief. 4.22. What is the ratio of the Aid flow from UN agencies (US$) of 2010 in Low & middle income to that in Sub-Saharan Africa (all income levels)?
Your answer should be very brief. 4.08. What is the ratio of the Aid flow from UN agencies (US$) in 2011 in Low & middle income to that in Sub-Saharan Africa (all income levels)?
Give a very brief answer. 4.25. What is the ratio of the Aid flow from UN agencies (US$) in 2012 in Low & middle income to that in Sub-Saharan Africa (all income levels)?
Your answer should be compact. 4.38. What is the ratio of the Aid flow from UN agencies (US$) of 2009 in Low & middle income to that in Sub-Saharan Africa (developing only)?
Make the answer very short. 4.22. What is the ratio of the Aid flow from UN agencies (US$) in 2010 in Low & middle income to that in Sub-Saharan Africa (developing only)?
Offer a very short reply. 4.08. What is the ratio of the Aid flow from UN agencies (US$) of 2011 in Low & middle income to that in Sub-Saharan Africa (developing only)?
Provide a succinct answer. 4.28. What is the ratio of the Aid flow from UN agencies (US$) in 2012 in Low & middle income to that in Sub-Saharan Africa (developing only)?
Provide a succinct answer. 4.41. What is the ratio of the Aid flow from UN agencies (US$) of 2009 in Middle income to that in Sub-Saharan Africa (all income levels)?
Give a very brief answer. 0.2. What is the ratio of the Aid flow from UN agencies (US$) of 2010 in Middle income to that in Sub-Saharan Africa (all income levels)?
Keep it short and to the point. 0.28. What is the ratio of the Aid flow from UN agencies (US$) in 2011 in Middle income to that in Sub-Saharan Africa (all income levels)?
Provide a succinct answer. 0.85. What is the ratio of the Aid flow from UN agencies (US$) in 2012 in Middle income to that in Sub-Saharan Africa (all income levels)?
Your answer should be very brief. 0.92. What is the ratio of the Aid flow from UN agencies (US$) of 2009 in Middle income to that in Sub-Saharan Africa (developing only)?
Keep it short and to the point. 0.2. What is the ratio of the Aid flow from UN agencies (US$) in 2010 in Middle income to that in Sub-Saharan Africa (developing only)?
Offer a very short reply. 0.28. What is the ratio of the Aid flow from UN agencies (US$) in 2011 in Middle income to that in Sub-Saharan Africa (developing only)?
Your response must be concise. 0.85. What is the ratio of the Aid flow from UN agencies (US$) in 2012 in Middle income to that in Sub-Saharan Africa (developing only)?
Make the answer very short. 0.93. What is the ratio of the Aid flow from UN agencies (US$) of 2009 in Sub-Saharan Africa (all income levels) to that in Sub-Saharan Africa (developing only)?
Provide a short and direct response. 1. What is the ratio of the Aid flow from UN agencies (US$) in 2011 in Sub-Saharan Africa (all income levels) to that in Sub-Saharan Africa (developing only)?
Make the answer very short. 1.01. What is the ratio of the Aid flow from UN agencies (US$) in 2012 in Sub-Saharan Africa (all income levels) to that in Sub-Saharan Africa (developing only)?
Your answer should be compact. 1.01. What is the difference between the highest and the second highest Aid flow from UN agencies (US$) of 2009?
Provide a succinct answer. 3.33e+08. What is the difference between the highest and the second highest Aid flow from UN agencies (US$) in 2010?
Provide a short and direct response. 2.76e+08. What is the difference between the highest and the second highest Aid flow from UN agencies (US$) in 2011?
Your answer should be very brief. 3.45e+08. What is the difference between the highest and the second highest Aid flow from UN agencies (US$) in 2012?
Offer a very short reply. 3.06e+08. What is the difference between the highest and the lowest Aid flow from UN agencies (US$) of 2009?
Your response must be concise. 4.16e+08. What is the difference between the highest and the lowest Aid flow from UN agencies (US$) of 2010?
Offer a terse response. 3.41e+08. What is the difference between the highest and the lowest Aid flow from UN agencies (US$) of 2011?
Your answer should be very brief. 4.13e+08. What is the difference between the highest and the lowest Aid flow from UN agencies (US$) in 2012?
Provide a short and direct response. 3.59e+08. 